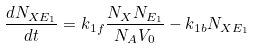Convert formula to latex. <formula><loc_0><loc_0><loc_500><loc_500>\frac { d N _ { X E _ { 1 } } } { d t } = k _ { 1 f } \frac { N _ { X } N _ { E _ { 1 } } } { N _ { A } V _ { 0 } } - k _ { 1 b } N _ { X E _ { 1 } }</formula> 